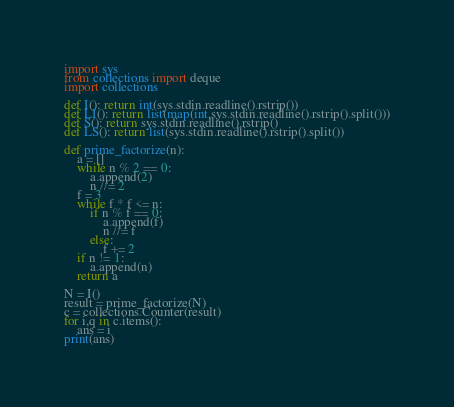<code> <loc_0><loc_0><loc_500><loc_500><_Python_>import sys
from collections import deque
import collections

def I(): return int(sys.stdin.readline().rstrip())
def LI(): return list(map(int,sys.stdin.readline().rstrip().split()))
def S(): return sys.stdin.readline().rstrip()
def LS(): return list(sys.stdin.readline().rstrip().split())

def prime_factorize(n):
    a = []
    while n % 2 == 0:
        a.append(2)
        n //= 2
    f = 3
    while f * f <= n:
        if n % f == 0:
            a.append(f)
            n //= f
        else:
            f += 2
    if n != 1:
        a.append(n)
    return a

N = I()
result = prime_factorize(N)
c = collections.Counter(result)
for i,q in c.items():
    ans = i
print(ans)</code> 